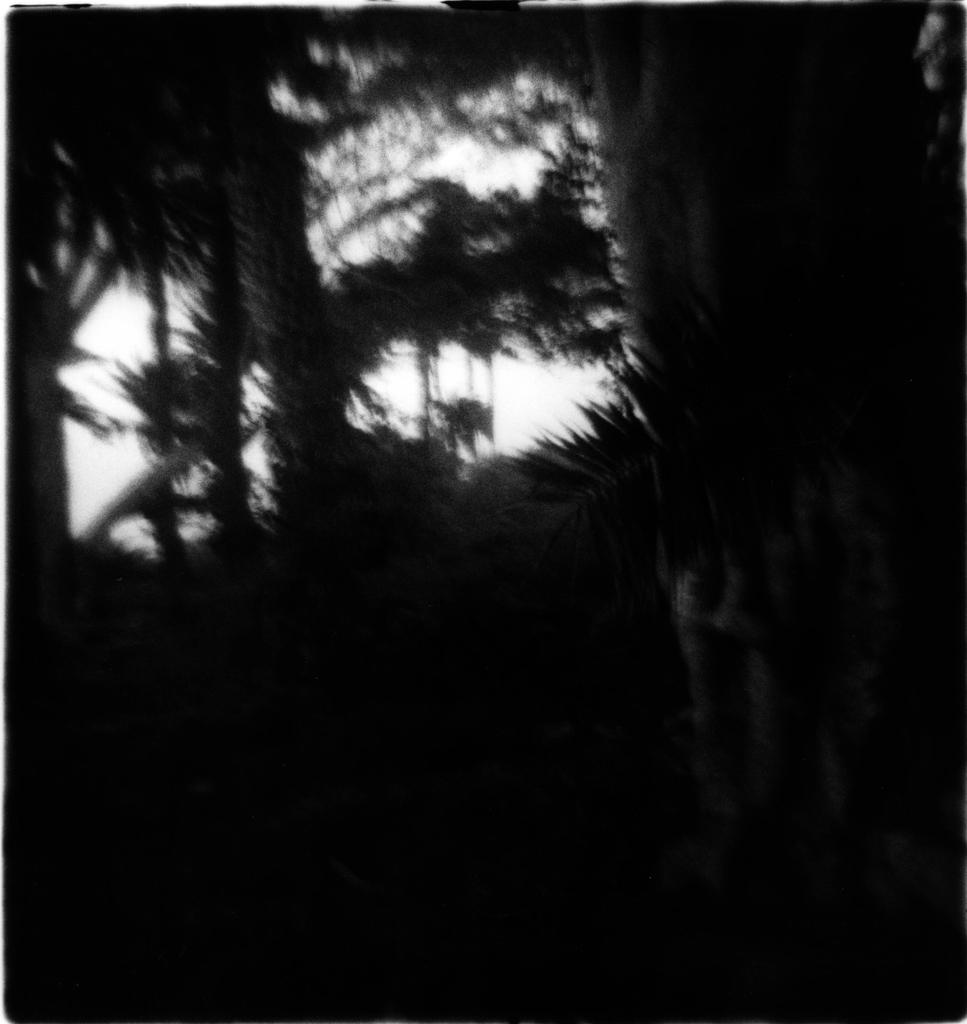What is the color scheme of the image? The image is black and white. What type of natural elements can be seen in the image? There are trees in the image. How many strings are hanging from the trees in the image? There are no strings visible in the image; only trees are present. Can you see any snakes slithering among the trees in the image? There are no snakes present in the image; only trees are visible. 